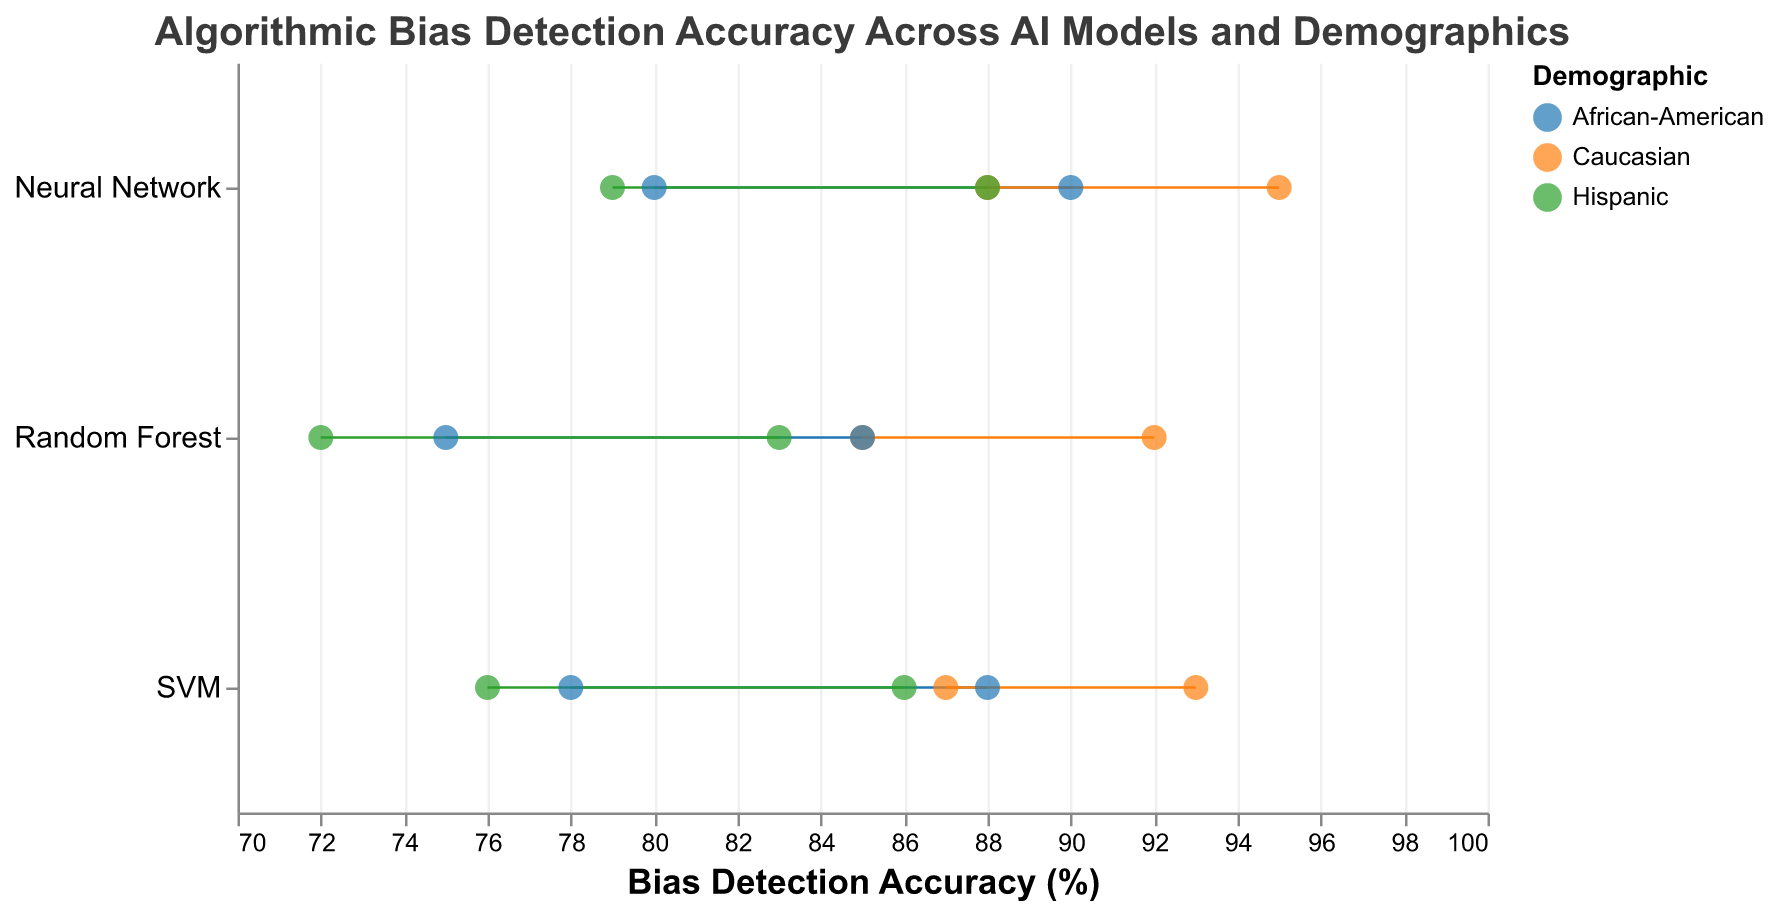How many AI models are compared in the figure? The figure visualizes results for three AI models across three demographics. This results in three AI models being represented for each demographic.
Answer: 3 What is the title of the figure? The title of the figure is located at the top and describes the content and purpose of the figure.
Answer: Algorithmic Bias Detection Accuracy Across AI Models and Demographics Which demographic has the highest maximum bias detection accuracy and what is that value? By looking at the end points of the dumbbells for each demographic, the maximum accuracy value for Caucasians can be identified to be the highest.
Answer: Caucasian, 95% What is the difference in maximum bias detection accuracy between the SVM model for Hispanic and African-American demographics? The maximum accuracy for Hispanic with SVM is 86% and for African-American with SVM is 88%. The difference is calculated as 88% - 86%.
Answer: 2% Among the AI models compared, which one shows the highest minimum bias detection accuracy? Examining the starting point (minimum accuracy) of the dumbbells, the Neural Network model for Caucasian shows the highest minimum accuracy.
Answer: Neural Network What is the range of bias detection accuracy for the Random Forest model involving Hispanic demographic? The minimum and maximum accuracy values can be found on the ends of the dumbbell for Random Forest and Hispanic demographic: the values are 72% and 83%. The range is calculated by 83% - 72%.
Answer: 11% Which AI model shows the smallest variation (range) in bias detection accuracy for the African-American demographic, and what is that range? The variation is calculated by subtracting the minimum accuracy from the maximum accuracy for each model. For Random Forest the range is 85% - 75% = 10%, for SVM it is 88% - 78% = 10%, and for Neural Network it is 90% - 80% = 10%. All variations turn out to be the same.
Answer: All have the same variation, 10% Which AI model has the uniform color across all demographics, and what is that color? The same AI model (e.g., Random Forest, SVM, or Neural Network) is represented by the same symbol (circle) across all demographics. Each demographic uses a unique color. Therefore what is the color for Random Forest?
Answer: #ff7f0e Is the Random Forest model more accurate for Caucasians or Hispanics in detecting bias? Comparing the min and max bias detection accuracy values of Random Forest for the two demographics, the values for Caucasians (85%-92%) can be compared to those for Hispanics (72%-83%).
Answer: Caucasians 